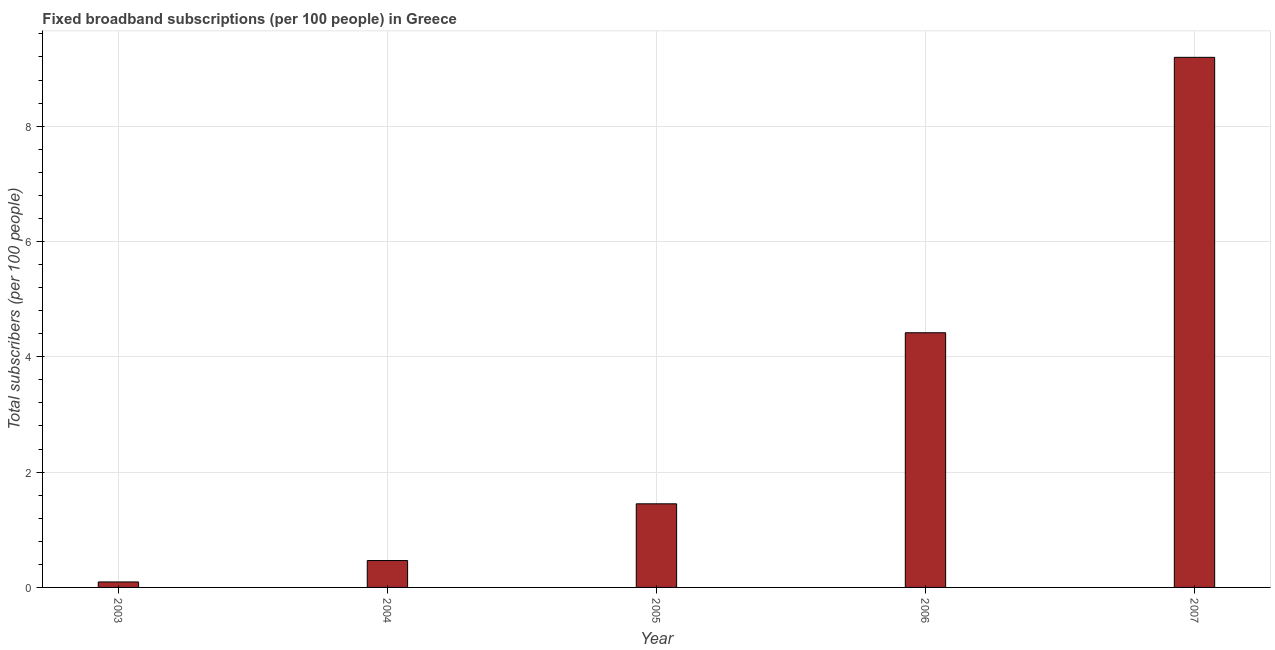Does the graph contain any zero values?
Your answer should be compact. No. Does the graph contain grids?
Provide a short and direct response. Yes. What is the title of the graph?
Give a very brief answer. Fixed broadband subscriptions (per 100 people) in Greece. What is the label or title of the X-axis?
Offer a very short reply. Year. What is the label or title of the Y-axis?
Your answer should be very brief. Total subscribers (per 100 people). What is the total number of fixed broadband subscriptions in 2006?
Offer a terse response. 4.42. Across all years, what is the maximum total number of fixed broadband subscriptions?
Ensure brevity in your answer.  9.19. Across all years, what is the minimum total number of fixed broadband subscriptions?
Keep it short and to the point. 0.09. In which year was the total number of fixed broadband subscriptions maximum?
Your answer should be very brief. 2007. In which year was the total number of fixed broadband subscriptions minimum?
Ensure brevity in your answer.  2003. What is the sum of the total number of fixed broadband subscriptions?
Provide a short and direct response. 15.62. What is the difference between the total number of fixed broadband subscriptions in 2004 and 2006?
Provide a succinct answer. -3.95. What is the average total number of fixed broadband subscriptions per year?
Ensure brevity in your answer.  3.12. What is the median total number of fixed broadband subscriptions?
Give a very brief answer. 1.45. Do a majority of the years between 2006 and 2007 (inclusive) have total number of fixed broadband subscriptions greater than 4.4 ?
Give a very brief answer. Yes. What is the ratio of the total number of fixed broadband subscriptions in 2005 to that in 2006?
Give a very brief answer. 0.33. Is the difference between the total number of fixed broadband subscriptions in 2004 and 2005 greater than the difference between any two years?
Provide a succinct answer. No. What is the difference between the highest and the second highest total number of fixed broadband subscriptions?
Offer a terse response. 4.78. Is the sum of the total number of fixed broadband subscriptions in 2003 and 2007 greater than the maximum total number of fixed broadband subscriptions across all years?
Provide a short and direct response. Yes. What is the difference between the highest and the lowest total number of fixed broadband subscriptions?
Offer a very short reply. 9.1. Are all the bars in the graph horizontal?
Your answer should be very brief. No. What is the difference between two consecutive major ticks on the Y-axis?
Offer a terse response. 2. Are the values on the major ticks of Y-axis written in scientific E-notation?
Offer a terse response. No. What is the Total subscribers (per 100 people) of 2003?
Give a very brief answer. 0.09. What is the Total subscribers (per 100 people) in 2004?
Your answer should be compact. 0.47. What is the Total subscribers (per 100 people) of 2005?
Offer a terse response. 1.45. What is the Total subscribers (per 100 people) in 2006?
Your answer should be very brief. 4.42. What is the Total subscribers (per 100 people) of 2007?
Your answer should be compact. 9.19. What is the difference between the Total subscribers (per 100 people) in 2003 and 2004?
Offer a terse response. -0.37. What is the difference between the Total subscribers (per 100 people) in 2003 and 2005?
Make the answer very short. -1.36. What is the difference between the Total subscribers (per 100 people) in 2003 and 2006?
Offer a very short reply. -4.32. What is the difference between the Total subscribers (per 100 people) in 2003 and 2007?
Keep it short and to the point. -9.1. What is the difference between the Total subscribers (per 100 people) in 2004 and 2005?
Keep it short and to the point. -0.98. What is the difference between the Total subscribers (per 100 people) in 2004 and 2006?
Offer a terse response. -3.95. What is the difference between the Total subscribers (per 100 people) in 2004 and 2007?
Make the answer very short. -8.73. What is the difference between the Total subscribers (per 100 people) in 2005 and 2006?
Provide a short and direct response. -2.97. What is the difference between the Total subscribers (per 100 people) in 2005 and 2007?
Ensure brevity in your answer.  -7.74. What is the difference between the Total subscribers (per 100 people) in 2006 and 2007?
Provide a short and direct response. -4.78. What is the ratio of the Total subscribers (per 100 people) in 2003 to that in 2004?
Offer a very short reply. 0.2. What is the ratio of the Total subscribers (per 100 people) in 2003 to that in 2005?
Provide a short and direct response. 0.07. What is the ratio of the Total subscribers (per 100 people) in 2003 to that in 2006?
Keep it short and to the point. 0.02. What is the ratio of the Total subscribers (per 100 people) in 2004 to that in 2005?
Give a very brief answer. 0.32. What is the ratio of the Total subscribers (per 100 people) in 2004 to that in 2006?
Make the answer very short. 0.11. What is the ratio of the Total subscribers (per 100 people) in 2004 to that in 2007?
Keep it short and to the point. 0.05. What is the ratio of the Total subscribers (per 100 people) in 2005 to that in 2006?
Your response must be concise. 0.33. What is the ratio of the Total subscribers (per 100 people) in 2005 to that in 2007?
Make the answer very short. 0.16. What is the ratio of the Total subscribers (per 100 people) in 2006 to that in 2007?
Your answer should be compact. 0.48. 